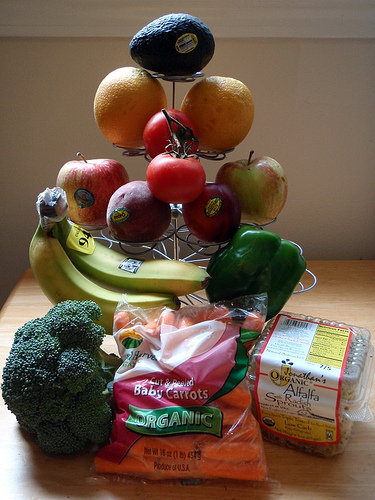Identify the text displayed in this image. Baby ORGANIC ORGANIC Jenathan's USA Sprouts Radish Alfalfs Cut Carrots 94 